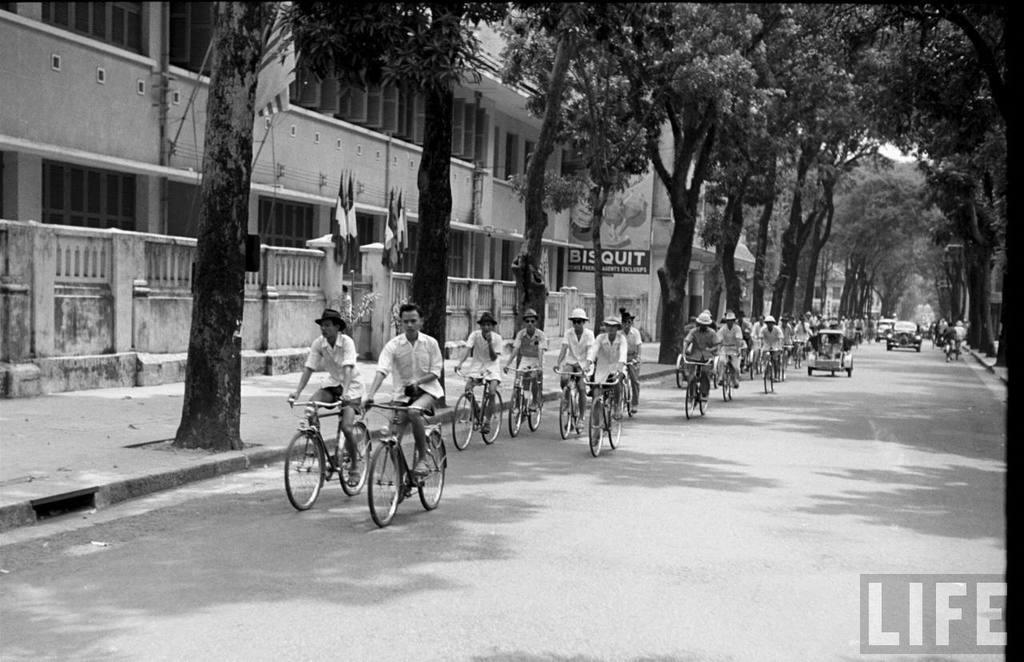Please provide a concise description of this image. In this image there are group of riding a bicycle on the road, there are cars and other vehicle on the road. There are trees on the both right and left side of the image. In the left side of the image there are flags at the entrance of the building. 